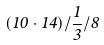Convert formula to latex. <formula><loc_0><loc_0><loc_500><loc_500>( 1 0 \cdot 1 4 ) / \frac { 1 } { 3 } / 8</formula> 